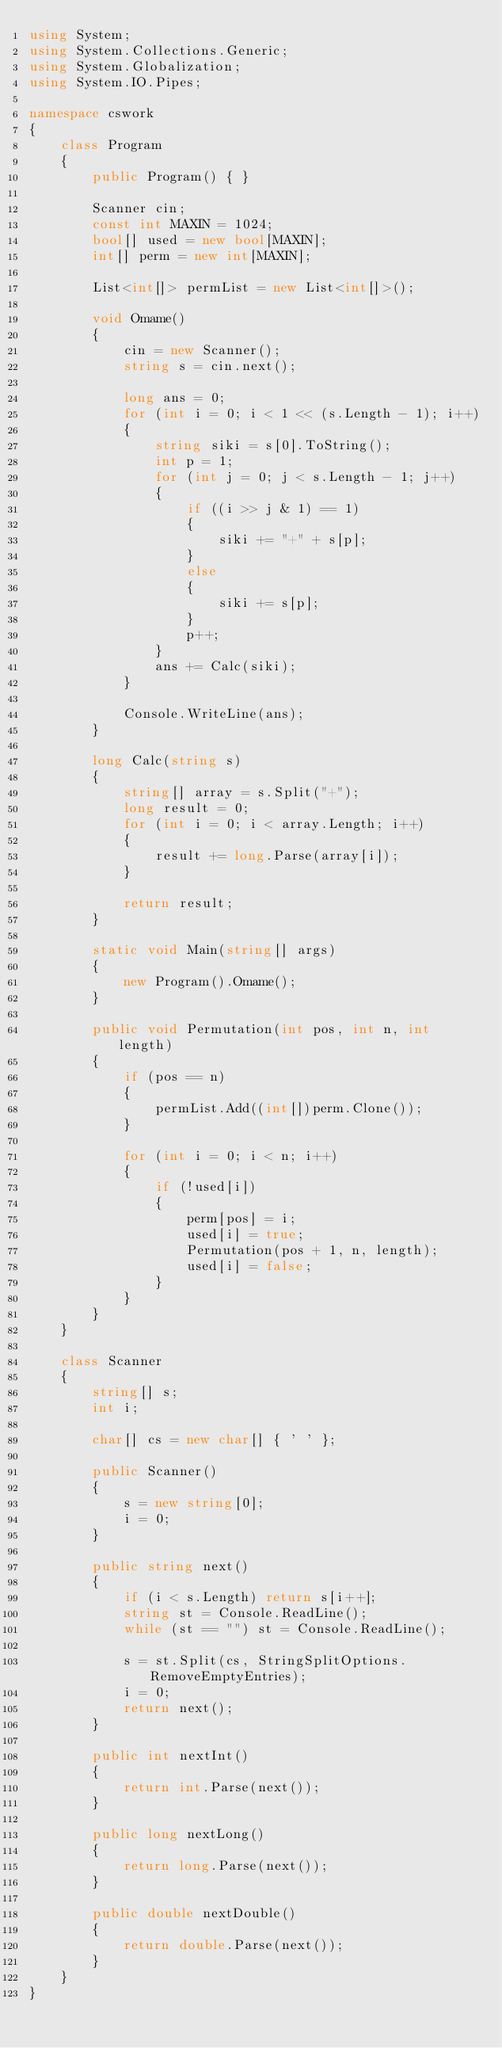<code> <loc_0><loc_0><loc_500><loc_500><_C#_>using System;
using System.Collections.Generic;
using System.Globalization;
using System.IO.Pipes;

namespace cswork
{
    class Program
    {
        public Program() { }

        Scanner cin;
        const int MAXIN = 1024;
        bool[] used = new bool[MAXIN];
        int[] perm = new int[MAXIN];

        List<int[]> permList = new List<int[]>();

        void Omame()
        {
            cin = new Scanner();
            string s = cin.next();

            long ans = 0;
            for (int i = 0; i < 1 << (s.Length - 1); i++)
            {
                string siki = s[0].ToString();
                int p = 1;
                for (int j = 0; j < s.Length - 1; j++)
                {
                    if ((i >> j & 1) == 1)
                    {
                        siki += "+" + s[p];
                    }
                    else
                    {
                        siki += s[p];
                    }
                    p++;
                }
                ans += Calc(siki);
            }

            Console.WriteLine(ans);
        }

        long Calc(string s)
        {
            string[] array = s.Split("+");
            long result = 0;
            for (int i = 0; i < array.Length; i++)
            {
                result += long.Parse(array[i]);
            }

            return result;
        }

        static void Main(string[] args)
        {
            new Program().Omame();
        }

        public void Permutation(int pos, int n, int length)
        {
            if (pos == n)
            {
                permList.Add((int[])perm.Clone());
            }

            for (int i = 0; i < n; i++)
            {
                if (!used[i])
                {
                    perm[pos] = i;
                    used[i] = true;
                    Permutation(pos + 1, n, length);
                    used[i] = false;
                }
            }
        }
    }

    class Scanner
    {
        string[] s;
        int i;

        char[] cs = new char[] { ' ' };

        public Scanner()
        {
            s = new string[0];
            i = 0;
        }

        public string next()
        {
            if (i < s.Length) return s[i++];
            string st = Console.ReadLine();
            while (st == "") st = Console.ReadLine();

            s = st.Split(cs, StringSplitOptions.RemoveEmptyEntries);
            i = 0;
            return next();
        }

        public int nextInt()
        {
            return int.Parse(next());
        }

        public long nextLong()
        {
            return long.Parse(next());
        }

        public double nextDouble()
        {
            return double.Parse(next());
        }
    }
}</code> 